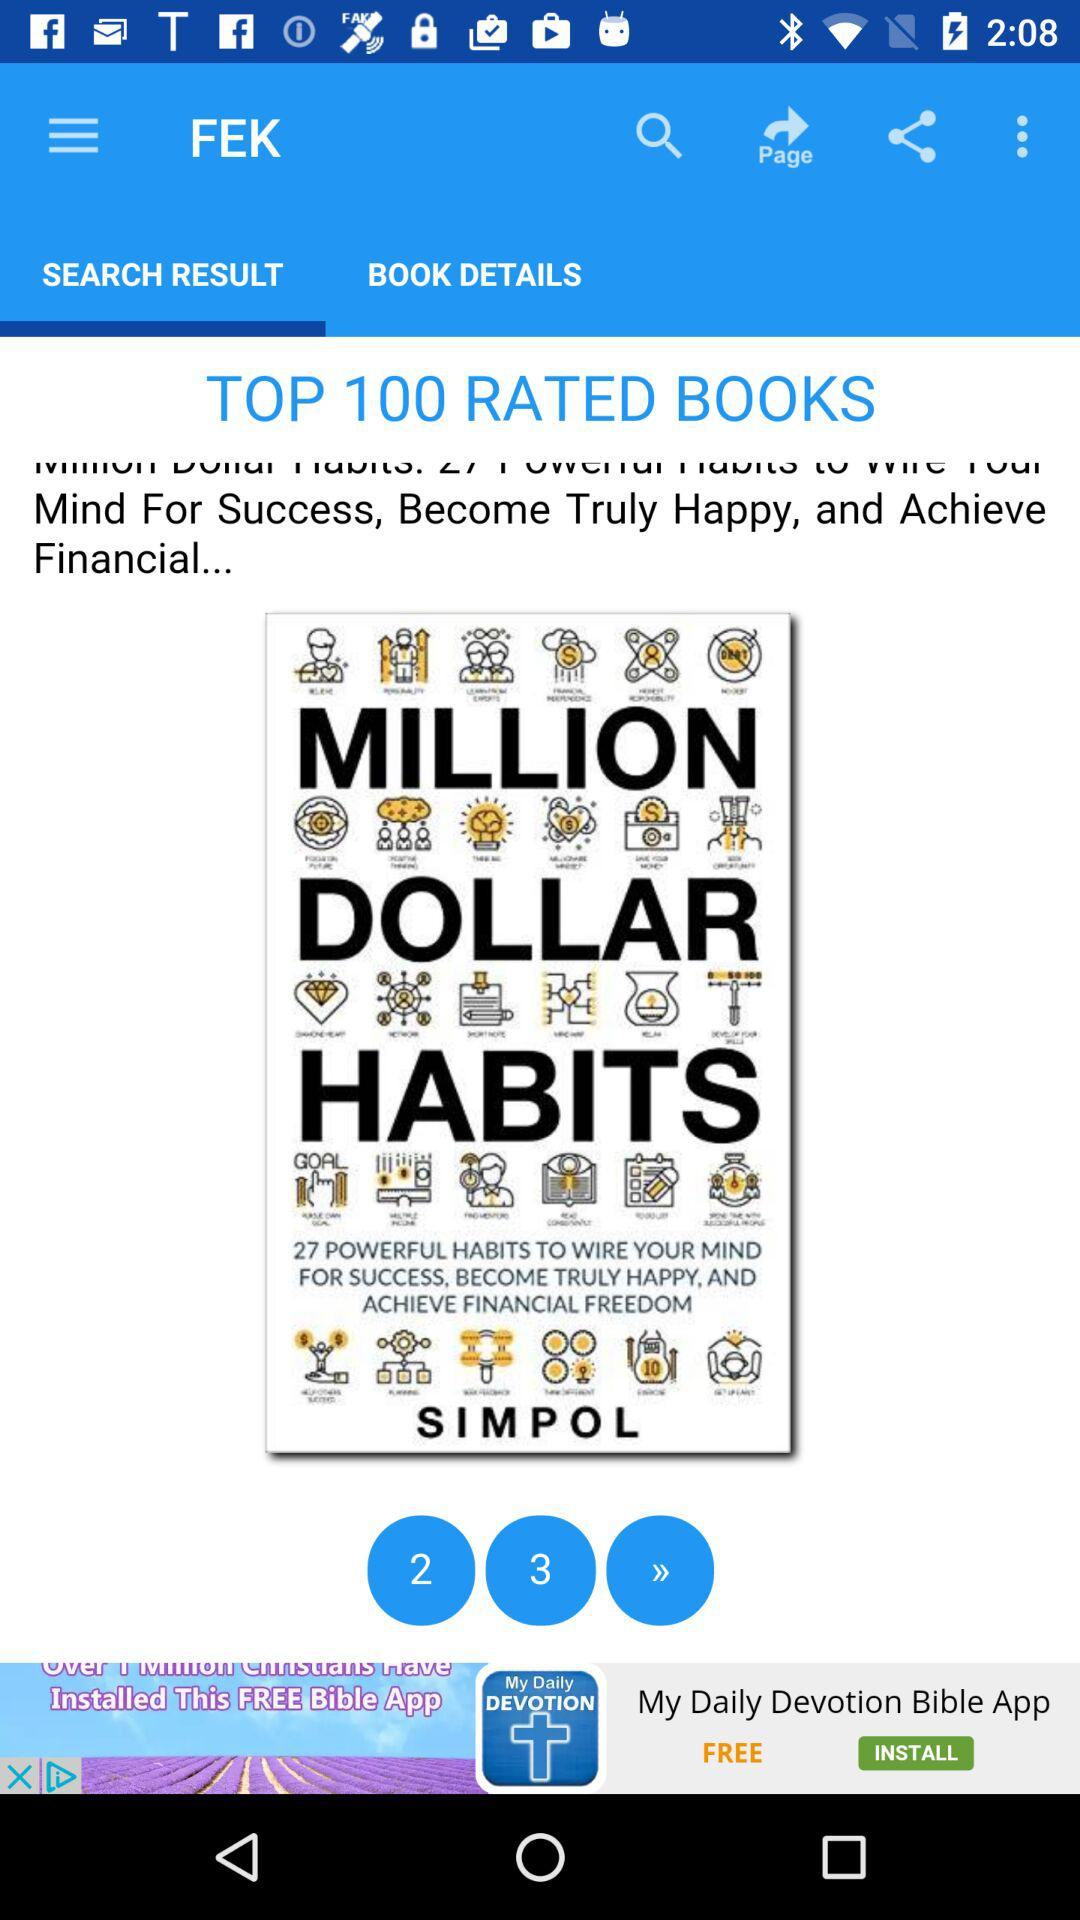What is the application name? The application name is "FEK". 